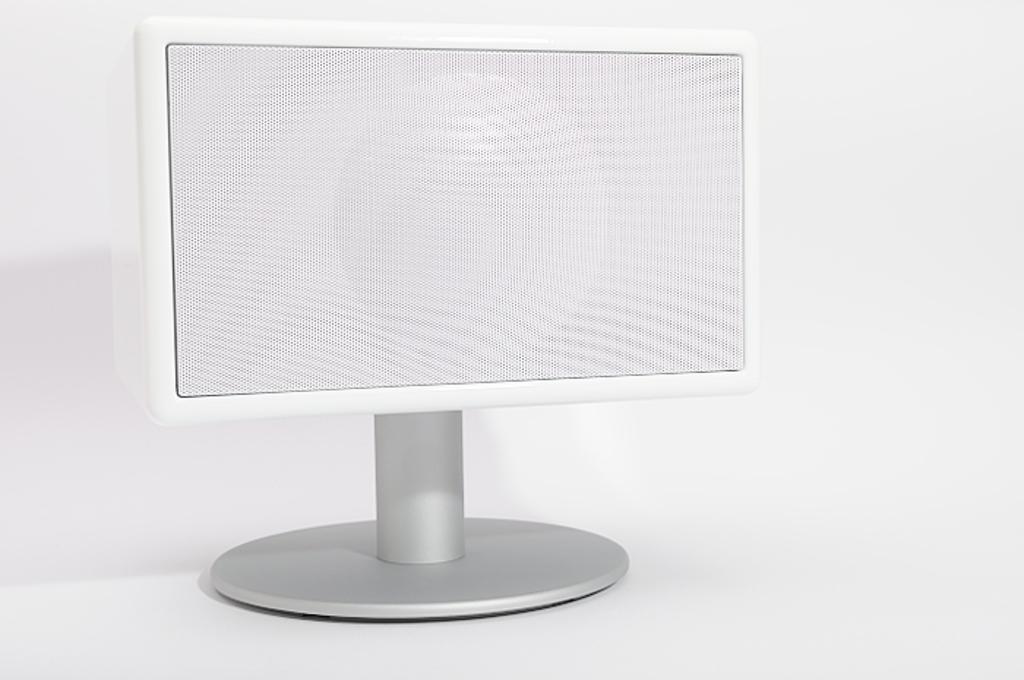How would you summarize this image in a sentence or two? In this image there is a white color monitor and there is a white color background. 